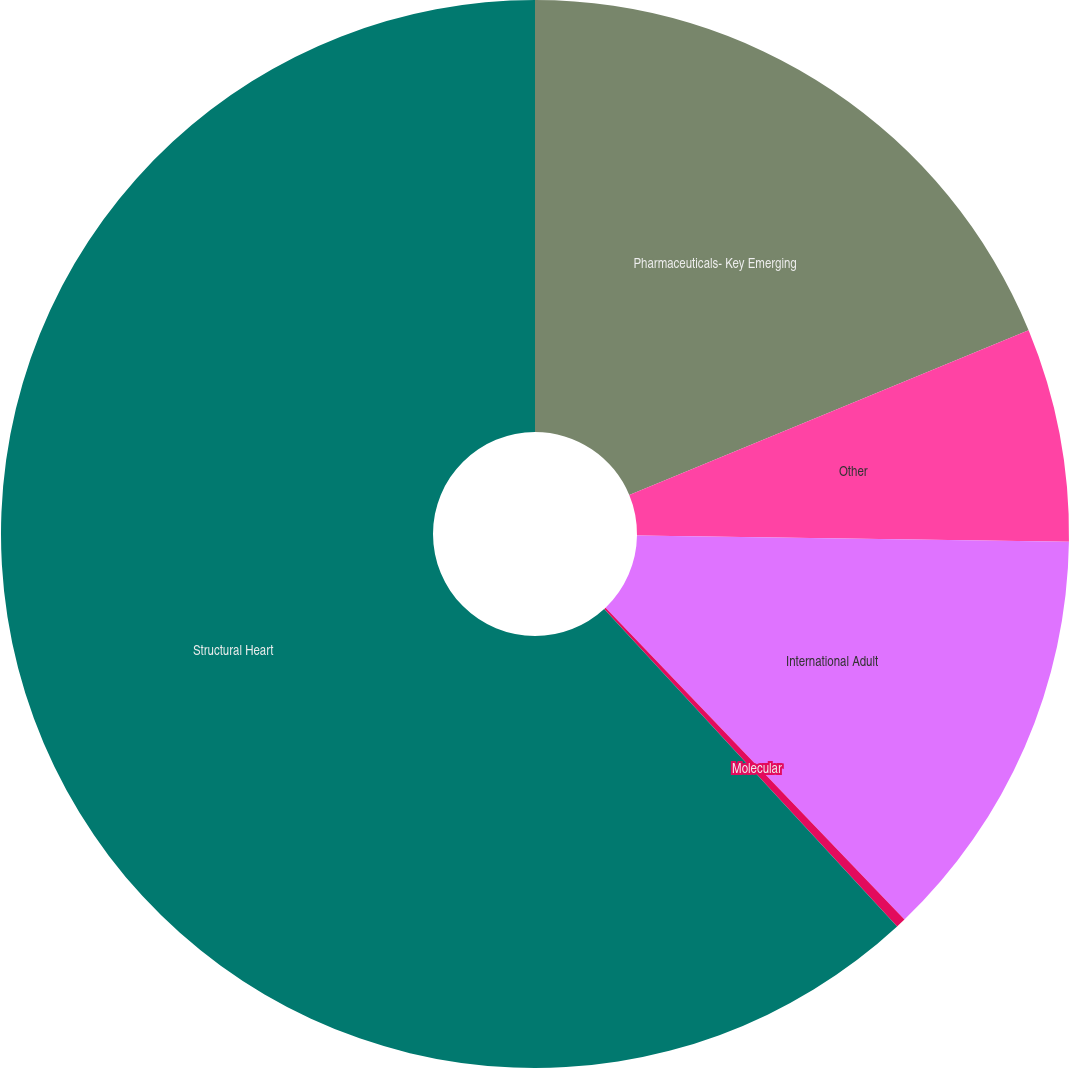Convert chart. <chart><loc_0><loc_0><loc_500><loc_500><pie_chart><fcel>Pharmaceuticals- Key Emerging<fcel>Other<fcel>International Adult<fcel>Molecular<fcel>Structural Heart<nl><fcel>18.77%<fcel>6.46%<fcel>12.61%<fcel>0.3%<fcel>61.86%<nl></chart> 